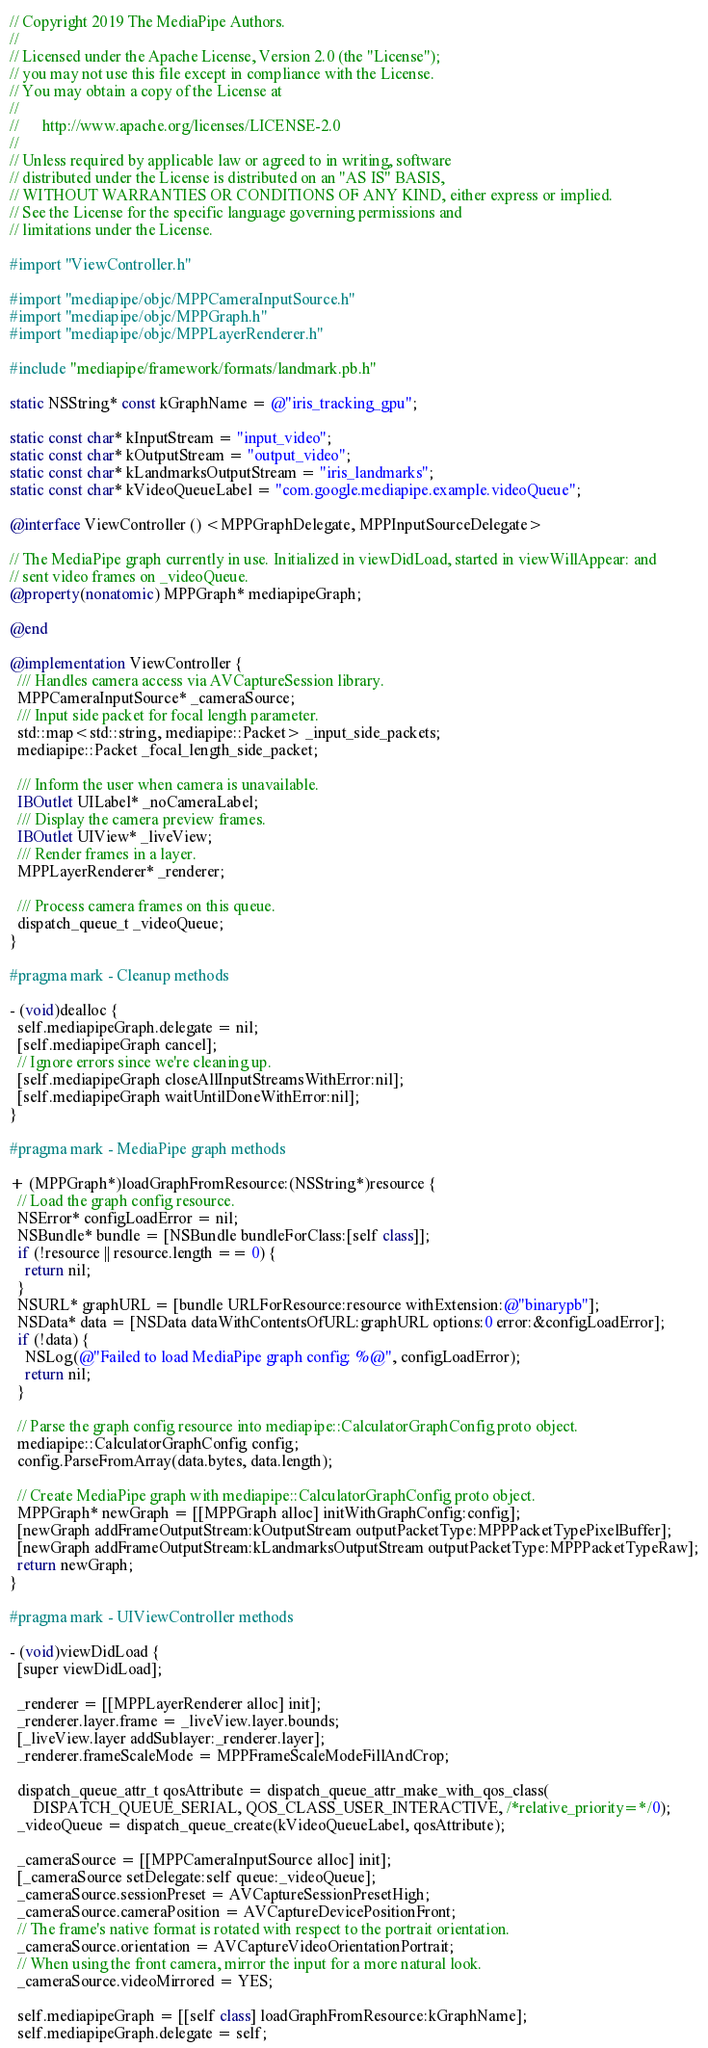<code> <loc_0><loc_0><loc_500><loc_500><_ObjectiveC_>// Copyright 2019 The MediaPipe Authors.
//
// Licensed under the Apache License, Version 2.0 (the "License");
// you may not use this file except in compliance with the License.
// You may obtain a copy of the License at
//
//      http://www.apache.org/licenses/LICENSE-2.0
//
// Unless required by applicable law or agreed to in writing, software
// distributed under the License is distributed on an "AS IS" BASIS,
// WITHOUT WARRANTIES OR CONDITIONS OF ANY KIND, either express or implied.
// See the License for the specific language governing permissions and
// limitations under the License.

#import "ViewController.h"

#import "mediapipe/objc/MPPCameraInputSource.h"
#import "mediapipe/objc/MPPGraph.h"
#import "mediapipe/objc/MPPLayerRenderer.h"

#include "mediapipe/framework/formats/landmark.pb.h"

static NSString* const kGraphName = @"iris_tracking_gpu";

static const char* kInputStream = "input_video";
static const char* kOutputStream = "output_video";
static const char* kLandmarksOutputStream = "iris_landmarks";
static const char* kVideoQueueLabel = "com.google.mediapipe.example.videoQueue";

@interface ViewController () <MPPGraphDelegate, MPPInputSourceDelegate>

// The MediaPipe graph currently in use. Initialized in viewDidLoad, started in viewWillAppear: and
// sent video frames on _videoQueue.
@property(nonatomic) MPPGraph* mediapipeGraph;

@end

@implementation ViewController {
  /// Handles camera access via AVCaptureSession library.
  MPPCameraInputSource* _cameraSource;
  /// Input side packet for focal length parameter.
  std::map<std::string, mediapipe::Packet> _input_side_packets;
  mediapipe::Packet _focal_length_side_packet;

  /// Inform the user when camera is unavailable.
  IBOutlet UILabel* _noCameraLabel;
  /// Display the camera preview frames.
  IBOutlet UIView* _liveView;
  /// Render frames in a layer.
  MPPLayerRenderer* _renderer;

  /// Process camera frames on this queue.
  dispatch_queue_t _videoQueue;
}

#pragma mark - Cleanup methods

- (void)dealloc {
  self.mediapipeGraph.delegate = nil;
  [self.mediapipeGraph cancel];
  // Ignore errors since we're cleaning up.
  [self.mediapipeGraph closeAllInputStreamsWithError:nil];
  [self.mediapipeGraph waitUntilDoneWithError:nil];
}

#pragma mark - MediaPipe graph methods

+ (MPPGraph*)loadGraphFromResource:(NSString*)resource {
  // Load the graph config resource.
  NSError* configLoadError = nil;
  NSBundle* bundle = [NSBundle bundleForClass:[self class]];
  if (!resource || resource.length == 0) {
    return nil;
  }
  NSURL* graphURL = [bundle URLForResource:resource withExtension:@"binarypb"];
  NSData* data = [NSData dataWithContentsOfURL:graphURL options:0 error:&configLoadError];
  if (!data) {
    NSLog(@"Failed to load MediaPipe graph config: %@", configLoadError);
    return nil;
  }

  // Parse the graph config resource into mediapipe::CalculatorGraphConfig proto object.
  mediapipe::CalculatorGraphConfig config;
  config.ParseFromArray(data.bytes, data.length);

  // Create MediaPipe graph with mediapipe::CalculatorGraphConfig proto object.
  MPPGraph* newGraph = [[MPPGraph alloc] initWithGraphConfig:config];
  [newGraph addFrameOutputStream:kOutputStream outputPacketType:MPPPacketTypePixelBuffer];
  [newGraph addFrameOutputStream:kLandmarksOutputStream outputPacketType:MPPPacketTypeRaw];
  return newGraph;
}

#pragma mark - UIViewController methods

- (void)viewDidLoad {
  [super viewDidLoad];

  _renderer = [[MPPLayerRenderer alloc] init];
  _renderer.layer.frame = _liveView.layer.bounds;
  [_liveView.layer addSublayer:_renderer.layer];
  _renderer.frameScaleMode = MPPFrameScaleModeFillAndCrop;

  dispatch_queue_attr_t qosAttribute = dispatch_queue_attr_make_with_qos_class(
      DISPATCH_QUEUE_SERIAL, QOS_CLASS_USER_INTERACTIVE, /*relative_priority=*/0);
  _videoQueue = dispatch_queue_create(kVideoQueueLabel, qosAttribute);

  _cameraSource = [[MPPCameraInputSource alloc] init];
  [_cameraSource setDelegate:self queue:_videoQueue];
  _cameraSource.sessionPreset = AVCaptureSessionPresetHigh;
  _cameraSource.cameraPosition = AVCaptureDevicePositionFront;
  // The frame's native format is rotated with respect to the portrait orientation.
  _cameraSource.orientation = AVCaptureVideoOrientationPortrait;
  // When using the front camera, mirror the input for a more natural look.
  _cameraSource.videoMirrored = YES;

  self.mediapipeGraph = [[self class] loadGraphFromResource:kGraphName];
  self.mediapipeGraph.delegate = self;</code> 